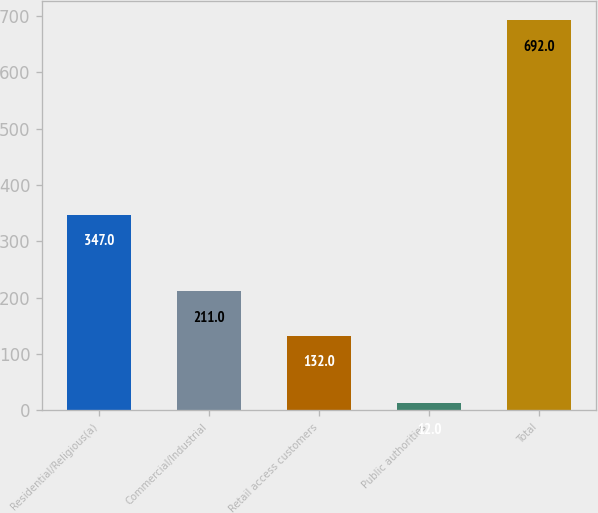<chart> <loc_0><loc_0><loc_500><loc_500><bar_chart><fcel>Residential/Religious(a)<fcel>Commercial/Industrial<fcel>Retail access customers<fcel>Public authorities<fcel>Total<nl><fcel>347<fcel>211<fcel>132<fcel>12<fcel>692<nl></chart> 